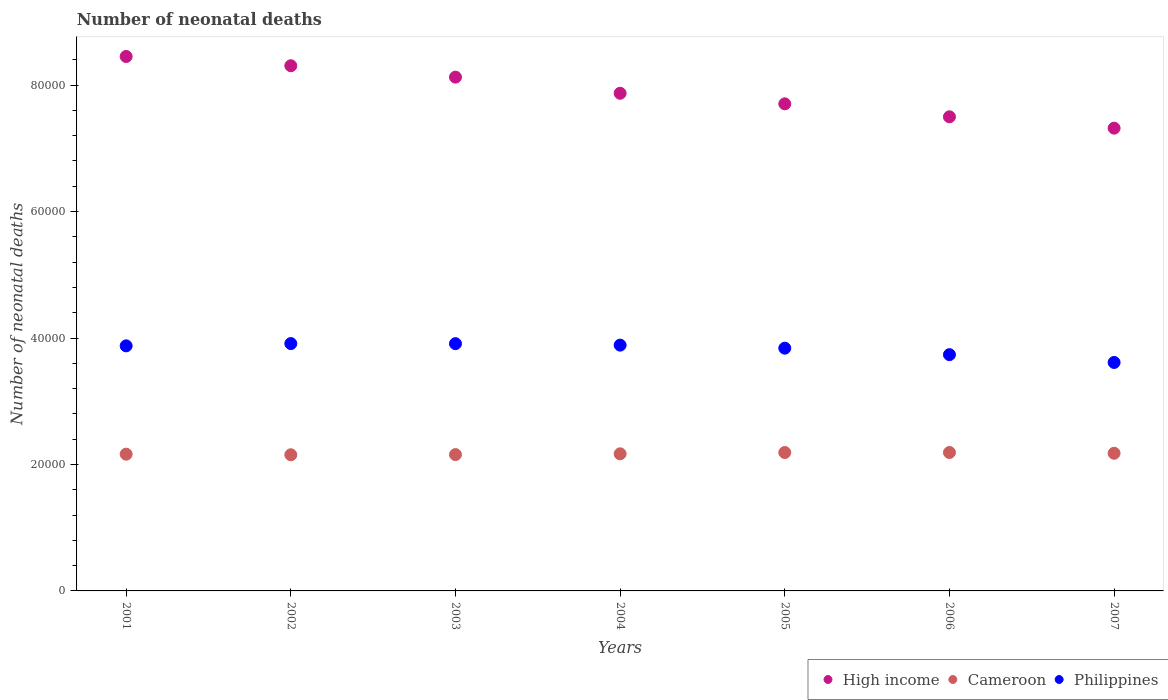How many different coloured dotlines are there?
Offer a very short reply. 3. What is the number of neonatal deaths in in Philippines in 2007?
Offer a very short reply. 3.61e+04. Across all years, what is the maximum number of neonatal deaths in in Philippines?
Give a very brief answer. 3.91e+04. Across all years, what is the minimum number of neonatal deaths in in High income?
Your response must be concise. 7.32e+04. In which year was the number of neonatal deaths in in Cameroon minimum?
Keep it short and to the point. 2002. What is the total number of neonatal deaths in in Philippines in the graph?
Provide a short and direct response. 2.68e+05. What is the difference between the number of neonatal deaths in in Cameroon in 2001 and that in 2002?
Keep it short and to the point. 98. What is the difference between the number of neonatal deaths in in Philippines in 2003 and the number of neonatal deaths in in High income in 2005?
Offer a terse response. -3.79e+04. What is the average number of neonatal deaths in in High income per year?
Keep it short and to the point. 7.90e+04. In the year 2006, what is the difference between the number of neonatal deaths in in High income and number of neonatal deaths in in Philippines?
Give a very brief answer. 3.76e+04. In how many years, is the number of neonatal deaths in in Philippines greater than 60000?
Your answer should be very brief. 0. What is the ratio of the number of neonatal deaths in in High income in 2001 to that in 2003?
Ensure brevity in your answer.  1.04. Is the number of neonatal deaths in in Philippines in 2001 less than that in 2003?
Ensure brevity in your answer.  Yes. What is the difference between the highest and the second highest number of neonatal deaths in in High income?
Your answer should be very brief. 1460. What is the difference between the highest and the lowest number of neonatal deaths in in Philippines?
Offer a terse response. 2985. Is the sum of the number of neonatal deaths in in Cameroon in 2004 and 2007 greater than the maximum number of neonatal deaths in in High income across all years?
Offer a very short reply. No. Is the number of neonatal deaths in in High income strictly greater than the number of neonatal deaths in in Cameroon over the years?
Give a very brief answer. Yes. Is the number of neonatal deaths in in Philippines strictly less than the number of neonatal deaths in in Cameroon over the years?
Keep it short and to the point. No. How many years are there in the graph?
Offer a terse response. 7. Does the graph contain grids?
Ensure brevity in your answer.  No. What is the title of the graph?
Your response must be concise. Number of neonatal deaths. Does "Korea (Republic)" appear as one of the legend labels in the graph?
Give a very brief answer. No. What is the label or title of the X-axis?
Offer a very short reply. Years. What is the label or title of the Y-axis?
Your response must be concise. Number of neonatal deaths. What is the Number of neonatal deaths of High income in 2001?
Ensure brevity in your answer.  8.45e+04. What is the Number of neonatal deaths of Cameroon in 2001?
Give a very brief answer. 2.16e+04. What is the Number of neonatal deaths in Philippines in 2001?
Give a very brief answer. 3.88e+04. What is the Number of neonatal deaths in High income in 2002?
Your response must be concise. 8.31e+04. What is the Number of neonatal deaths in Cameroon in 2002?
Offer a very short reply. 2.15e+04. What is the Number of neonatal deaths of Philippines in 2002?
Your response must be concise. 3.91e+04. What is the Number of neonatal deaths of High income in 2003?
Make the answer very short. 8.13e+04. What is the Number of neonatal deaths in Cameroon in 2003?
Provide a succinct answer. 2.16e+04. What is the Number of neonatal deaths in Philippines in 2003?
Offer a very short reply. 3.91e+04. What is the Number of neonatal deaths in High income in 2004?
Offer a very short reply. 7.87e+04. What is the Number of neonatal deaths of Cameroon in 2004?
Provide a succinct answer. 2.17e+04. What is the Number of neonatal deaths of Philippines in 2004?
Your answer should be very brief. 3.89e+04. What is the Number of neonatal deaths of High income in 2005?
Give a very brief answer. 7.70e+04. What is the Number of neonatal deaths in Cameroon in 2005?
Provide a short and direct response. 2.19e+04. What is the Number of neonatal deaths of Philippines in 2005?
Your answer should be very brief. 3.84e+04. What is the Number of neonatal deaths of High income in 2006?
Keep it short and to the point. 7.50e+04. What is the Number of neonatal deaths in Cameroon in 2006?
Provide a succinct answer. 2.19e+04. What is the Number of neonatal deaths of Philippines in 2006?
Give a very brief answer. 3.74e+04. What is the Number of neonatal deaths in High income in 2007?
Provide a short and direct response. 7.32e+04. What is the Number of neonatal deaths in Cameroon in 2007?
Keep it short and to the point. 2.18e+04. What is the Number of neonatal deaths in Philippines in 2007?
Your answer should be compact. 3.61e+04. Across all years, what is the maximum Number of neonatal deaths in High income?
Provide a short and direct response. 8.45e+04. Across all years, what is the maximum Number of neonatal deaths in Cameroon?
Provide a succinct answer. 2.19e+04. Across all years, what is the maximum Number of neonatal deaths in Philippines?
Provide a succinct answer. 3.91e+04. Across all years, what is the minimum Number of neonatal deaths of High income?
Ensure brevity in your answer.  7.32e+04. Across all years, what is the minimum Number of neonatal deaths of Cameroon?
Ensure brevity in your answer.  2.15e+04. Across all years, what is the minimum Number of neonatal deaths in Philippines?
Make the answer very short. 3.61e+04. What is the total Number of neonatal deaths of High income in the graph?
Your answer should be compact. 5.53e+05. What is the total Number of neonatal deaths in Cameroon in the graph?
Your answer should be very brief. 1.52e+05. What is the total Number of neonatal deaths in Philippines in the graph?
Give a very brief answer. 2.68e+05. What is the difference between the Number of neonatal deaths in High income in 2001 and that in 2002?
Provide a succinct answer. 1460. What is the difference between the Number of neonatal deaths of Cameroon in 2001 and that in 2002?
Offer a terse response. 98. What is the difference between the Number of neonatal deaths in Philippines in 2001 and that in 2002?
Keep it short and to the point. -358. What is the difference between the Number of neonatal deaths in High income in 2001 and that in 2003?
Provide a short and direct response. 3265. What is the difference between the Number of neonatal deaths in Philippines in 2001 and that in 2003?
Your answer should be compact. -346. What is the difference between the Number of neonatal deaths in High income in 2001 and that in 2004?
Provide a short and direct response. 5818. What is the difference between the Number of neonatal deaths of Cameroon in 2001 and that in 2004?
Offer a terse response. -57. What is the difference between the Number of neonatal deaths of Philippines in 2001 and that in 2004?
Offer a very short reply. -114. What is the difference between the Number of neonatal deaths of High income in 2001 and that in 2005?
Offer a very short reply. 7489. What is the difference between the Number of neonatal deaths in Cameroon in 2001 and that in 2005?
Your answer should be compact. -260. What is the difference between the Number of neonatal deaths of Philippines in 2001 and that in 2005?
Provide a succinct answer. 367. What is the difference between the Number of neonatal deaths of High income in 2001 and that in 2006?
Your response must be concise. 9539. What is the difference between the Number of neonatal deaths of Cameroon in 2001 and that in 2006?
Your response must be concise. -264. What is the difference between the Number of neonatal deaths of Philippines in 2001 and that in 2006?
Provide a succinct answer. 1392. What is the difference between the Number of neonatal deaths of High income in 2001 and that in 2007?
Give a very brief answer. 1.13e+04. What is the difference between the Number of neonatal deaths of Cameroon in 2001 and that in 2007?
Give a very brief answer. -143. What is the difference between the Number of neonatal deaths in Philippines in 2001 and that in 2007?
Offer a very short reply. 2627. What is the difference between the Number of neonatal deaths of High income in 2002 and that in 2003?
Make the answer very short. 1805. What is the difference between the Number of neonatal deaths of Cameroon in 2002 and that in 2003?
Offer a terse response. -30. What is the difference between the Number of neonatal deaths in Philippines in 2002 and that in 2003?
Make the answer very short. 12. What is the difference between the Number of neonatal deaths in High income in 2002 and that in 2004?
Provide a short and direct response. 4358. What is the difference between the Number of neonatal deaths in Cameroon in 2002 and that in 2004?
Provide a succinct answer. -155. What is the difference between the Number of neonatal deaths of Philippines in 2002 and that in 2004?
Keep it short and to the point. 244. What is the difference between the Number of neonatal deaths in High income in 2002 and that in 2005?
Ensure brevity in your answer.  6029. What is the difference between the Number of neonatal deaths of Cameroon in 2002 and that in 2005?
Provide a short and direct response. -358. What is the difference between the Number of neonatal deaths in Philippines in 2002 and that in 2005?
Give a very brief answer. 725. What is the difference between the Number of neonatal deaths in High income in 2002 and that in 2006?
Make the answer very short. 8079. What is the difference between the Number of neonatal deaths of Cameroon in 2002 and that in 2006?
Give a very brief answer. -362. What is the difference between the Number of neonatal deaths in Philippines in 2002 and that in 2006?
Give a very brief answer. 1750. What is the difference between the Number of neonatal deaths of High income in 2002 and that in 2007?
Your response must be concise. 9875. What is the difference between the Number of neonatal deaths of Cameroon in 2002 and that in 2007?
Offer a very short reply. -241. What is the difference between the Number of neonatal deaths in Philippines in 2002 and that in 2007?
Ensure brevity in your answer.  2985. What is the difference between the Number of neonatal deaths of High income in 2003 and that in 2004?
Make the answer very short. 2553. What is the difference between the Number of neonatal deaths in Cameroon in 2003 and that in 2004?
Offer a terse response. -125. What is the difference between the Number of neonatal deaths of Philippines in 2003 and that in 2004?
Keep it short and to the point. 232. What is the difference between the Number of neonatal deaths in High income in 2003 and that in 2005?
Your answer should be very brief. 4224. What is the difference between the Number of neonatal deaths in Cameroon in 2003 and that in 2005?
Your answer should be compact. -328. What is the difference between the Number of neonatal deaths of Philippines in 2003 and that in 2005?
Make the answer very short. 713. What is the difference between the Number of neonatal deaths of High income in 2003 and that in 2006?
Keep it short and to the point. 6274. What is the difference between the Number of neonatal deaths in Cameroon in 2003 and that in 2006?
Make the answer very short. -332. What is the difference between the Number of neonatal deaths in Philippines in 2003 and that in 2006?
Ensure brevity in your answer.  1738. What is the difference between the Number of neonatal deaths in High income in 2003 and that in 2007?
Your answer should be compact. 8070. What is the difference between the Number of neonatal deaths of Cameroon in 2003 and that in 2007?
Keep it short and to the point. -211. What is the difference between the Number of neonatal deaths of Philippines in 2003 and that in 2007?
Give a very brief answer. 2973. What is the difference between the Number of neonatal deaths of High income in 2004 and that in 2005?
Provide a succinct answer. 1671. What is the difference between the Number of neonatal deaths of Cameroon in 2004 and that in 2005?
Offer a terse response. -203. What is the difference between the Number of neonatal deaths of Philippines in 2004 and that in 2005?
Give a very brief answer. 481. What is the difference between the Number of neonatal deaths of High income in 2004 and that in 2006?
Offer a very short reply. 3721. What is the difference between the Number of neonatal deaths of Cameroon in 2004 and that in 2006?
Ensure brevity in your answer.  -207. What is the difference between the Number of neonatal deaths in Philippines in 2004 and that in 2006?
Ensure brevity in your answer.  1506. What is the difference between the Number of neonatal deaths of High income in 2004 and that in 2007?
Your answer should be compact. 5517. What is the difference between the Number of neonatal deaths of Cameroon in 2004 and that in 2007?
Make the answer very short. -86. What is the difference between the Number of neonatal deaths of Philippines in 2004 and that in 2007?
Give a very brief answer. 2741. What is the difference between the Number of neonatal deaths in High income in 2005 and that in 2006?
Offer a very short reply. 2050. What is the difference between the Number of neonatal deaths in Cameroon in 2005 and that in 2006?
Give a very brief answer. -4. What is the difference between the Number of neonatal deaths of Philippines in 2005 and that in 2006?
Your answer should be very brief. 1025. What is the difference between the Number of neonatal deaths in High income in 2005 and that in 2007?
Ensure brevity in your answer.  3846. What is the difference between the Number of neonatal deaths of Cameroon in 2005 and that in 2007?
Keep it short and to the point. 117. What is the difference between the Number of neonatal deaths of Philippines in 2005 and that in 2007?
Your answer should be very brief. 2260. What is the difference between the Number of neonatal deaths of High income in 2006 and that in 2007?
Provide a short and direct response. 1796. What is the difference between the Number of neonatal deaths of Cameroon in 2006 and that in 2007?
Ensure brevity in your answer.  121. What is the difference between the Number of neonatal deaths in Philippines in 2006 and that in 2007?
Give a very brief answer. 1235. What is the difference between the Number of neonatal deaths in High income in 2001 and the Number of neonatal deaths in Cameroon in 2002?
Provide a short and direct response. 6.30e+04. What is the difference between the Number of neonatal deaths of High income in 2001 and the Number of neonatal deaths of Philippines in 2002?
Provide a short and direct response. 4.54e+04. What is the difference between the Number of neonatal deaths in Cameroon in 2001 and the Number of neonatal deaths in Philippines in 2002?
Offer a very short reply. -1.75e+04. What is the difference between the Number of neonatal deaths in High income in 2001 and the Number of neonatal deaths in Cameroon in 2003?
Your answer should be compact. 6.30e+04. What is the difference between the Number of neonatal deaths of High income in 2001 and the Number of neonatal deaths of Philippines in 2003?
Your response must be concise. 4.54e+04. What is the difference between the Number of neonatal deaths of Cameroon in 2001 and the Number of neonatal deaths of Philippines in 2003?
Your answer should be compact. -1.75e+04. What is the difference between the Number of neonatal deaths of High income in 2001 and the Number of neonatal deaths of Cameroon in 2004?
Offer a terse response. 6.28e+04. What is the difference between the Number of neonatal deaths of High income in 2001 and the Number of neonatal deaths of Philippines in 2004?
Provide a succinct answer. 4.57e+04. What is the difference between the Number of neonatal deaths in Cameroon in 2001 and the Number of neonatal deaths in Philippines in 2004?
Give a very brief answer. -1.72e+04. What is the difference between the Number of neonatal deaths of High income in 2001 and the Number of neonatal deaths of Cameroon in 2005?
Offer a terse response. 6.26e+04. What is the difference between the Number of neonatal deaths of High income in 2001 and the Number of neonatal deaths of Philippines in 2005?
Provide a succinct answer. 4.61e+04. What is the difference between the Number of neonatal deaths of Cameroon in 2001 and the Number of neonatal deaths of Philippines in 2005?
Your response must be concise. -1.68e+04. What is the difference between the Number of neonatal deaths of High income in 2001 and the Number of neonatal deaths of Cameroon in 2006?
Your response must be concise. 6.26e+04. What is the difference between the Number of neonatal deaths of High income in 2001 and the Number of neonatal deaths of Philippines in 2006?
Ensure brevity in your answer.  4.72e+04. What is the difference between the Number of neonatal deaths in Cameroon in 2001 and the Number of neonatal deaths in Philippines in 2006?
Your answer should be compact. -1.57e+04. What is the difference between the Number of neonatal deaths in High income in 2001 and the Number of neonatal deaths in Cameroon in 2007?
Offer a terse response. 6.28e+04. What is the difference between the Number of neonatal deaths of High income in 2001 and the Number of neonatal deaths of Philippines in 2007?
Give a very brief answer. 4.84e+04. What is the difference between the Number of neonatal deaths in Cameroon in 2001 and the Number of neonatal deaths in Philippines in 2007?
Give a very brief answer. -1.45e+04. What is the difference between the Number of neonatal deaths of High income in 2002 and the Number of neonatal deaths of Cameroon in 2003?
Your answer should be compact. 6.15e+04. What is the difference between the Number of neonatal deaths of High income in 2002 and the Number of neonatal deaths of Philippines in 2003?
Ensure brevity in your answer.  4.40e+04. What is the difference between the Number of neonatal deaths of Cameroon in 2002 and the Number of neonatal deaths of Philippines in 2003?
Offer a terse response. -1.76e+04. What is the difference between the Number of neonatal deaths in High income in 2002 and the Number of neonatal deaths in Cameroon in 2004?
Keep it short and to the point. 6.14e+04. What is the difference between the Number of neonatal deaths of High income in 2002 and the Number of neonatal deaths of Philippines in 2004?
Ensure brevity in your answer.  4.42e+04. What is the difference between the Number of neonatal deaths of Cameroon in 2002 and the Number of neonatal deaths of Philippines in 2004?
Offer a very short reply. -1.73e+04. What is the difference between the Number of neonatal deaths in High income in 2002 and the Number of neonatal deaths in Cameroon in 2005?
Provide a short and direct response. 6.12e+04. What is the difference between the Number of neonatal deaths in High income in 2002 and the Number of neonatal deaths in Philippines in 2005?
Your response must be concise. 4.47e+04. What is the difference between the Number of neonatal deaths in Cameroon in 2002 and the Number of neonatal deaths in Philippines in 2005?
Ensure brevity in your answer.  -1.69e+04. What is the difference between the Number of neonatal deaths of High income in 2002 and the Number of neonatal deaths of Cameroon in 2006?
Offer a very short reply. 6.12e+04. What is the difference between the Number of neonatal deaths in High income in 2002 and the Number of neonatal deaths in Philippines in 2006?
Your answer should be very brief. 4.57e+04. What is the difference between the Number of neonatal deaths of Cameroon in 2002 and the Number of neonatal deaths of Philippines in 2006?
Provide a succinct answer. -1.58e+04. What is the difference between the Number of neonatal deaths of High income in 2002 and the Number of neonatal deaths of Cameroon in 2007?
Provide a succinct answer. 6.13e+04. What is the difference between the Number of neonatal deaths in High income in 2002 and the Number of neonatal deaths in Philippines in 2007?
Offer a terse response. 4.69e+04. What is the difference between the Number of neonatal deaths in Cameroon in 2002 and the Number of neonatal deaths in Philippines in 2007?
Keep it short and to the point. -1.46e+04. What is the difference between the Number of neonatal deaths of High income in 2003 and the Number of neonatal deaths of Cameroon in 2004?
Give a very brief answer. 5.96e+04. What is the difference between the Number of neonatal deaths of High income in 2003 and the Number of neonatal deaths of Philippines in 2004?
Offer a terse response. 4.24e+04. What is the difference between the Number of neonatal deaths in Cameroon in 2003 and the Number of neonatal deaths in Philippines in 2004?
Your answer should be compact. -1.73e+04. What is the difference between the Number of neonatal deaths in High income in 2003 and the Number of neonatal deaths in Cameroon in 2005?
Ensure brevity in your answer.  5.94e+04. What is the difference between the Number of neonatal deaths in High income in 2003 and the Number of neonatal deaths in Philippines in 2005?
Your response must be concise. 4.29e+04. What is the difference between the Number of neonatal deaths in Cameroon in 2003 and the Number of neonatal deaths in Philippines in 2005?
Make the answer very short. -1.68e+04. What is the difference between the Number of neonatal deaths in High income in 2003 and the Number of neonatal deaths in Cameroon in 2006?
Your answer should be compact. 5.94e+04. What is the difference between the Number of neonatal deaths in High income in 2003 and the Number of neonatal deaths in Philippines in 2006?
Give a very brief answer. 4.39e+04. What is the difference between the Number of neonatal deaths of Cameroon in 2003 and the Number of neonatal deaths of Philippines in 2006?
Your answer should be compact. -1.58e+04. What is the difference between the Number of neonatal deaths in High income in 2003 and the Number of neonatal deaths in Cameroon in 2007?
Provide a succinct answer. 5.95e+04. What is the difference between the Number of neonatal deaths in High income in 2003 and the Number of neonatal deaths in Philippines in 2007?
Your answer should be compact. 4.51e+04. What is the difference between the Number of neonatal deaths in Cameroon in 2003 and the Number of neonatal deaths in Philippines in 2007?
Your answer should be very brief. -1.46e+04. What is the difference between the Number of neonatal deaths in High income in 2004 and the Number of neonatal deaths in Cameroon in 2005?
Offer a terse response. 5.68e+04. What is the difference between the Number of neonatal deaths of High income in 2004 and the Number of neonatal deaths of Philippines in 2005?
Ensure brevity in your answer.  4.03e+04. What is the difference between the Number of neonatal deaths of Cameroon in 2004 and the Number of neonatal deaths of Philippines in 2005?
Ensure brevity in your answer.  -1.67e+04. What is the difference between the Number of neonatal deaths in High income in 2004 and the Number of neonatal deaths in Cameroon in 2006?
Ensure brevity in your answer.  5.68e+04. What is the difference between the Number of neonatal deaths in High income in 2004 and the Number of neonatal deaths in Philippines in 2006?
Keep it short and to the point. 4.13e+04. What is the difference between the Number of neonatal deaths in Cameroon in 2004 and the Number of neonatal deaths in Philippines in 2006?
Offer a terse response. -1.57e+04. What is the difference between the Number of neonatal deaths in High income in 2004 and the Number of neonatal deaths in Cameroon in 2007?
Give a very brief answer. 5.69e+04. What is the difference between the Number of neonatal deaths of High income in 2004 and the Number of neonatal deaths of Philippines in 2007?
Your answer should be very brief. 4.26e+04. What is the difference between the Number of neonatal deaths of Cameroon in 2004 and the Number of neonatal deaths of Philippines in 2007?
Make the answer very short. -1.44e+04. What is the difference between the Number of neonatal deaths in High income in 2005 and the Number of neonatal deaths in Cameroon in 2006?
Your answer should be very brief. 5.51e+04. What is the difference between the Number of neonatal deaths of High income in 2005 and the Number of neonatal deaths of Philippines in 2006?
Make the answer very short. 3.97e+04. What is the difference between the Number of neonatal deaths of Cameroon in 2005 and the Number of neonatal deaths of Philippines in 2006?
Your answer should be compact. -1.55e+04. What is the difference between the Number of neonatal deaths of High income in 2005 and the Number of neonatal deaths of Cameroon in 2007?
Give a very brief answer. 5.53e+04. What is the difference between the Number of neonatal deaths of High income in 2005 and the Number of neonatal deaths of Philippines in 2007?
Make the answer very short. 4.09e+04. What is the difference between the Number of neonatal deaths of Cameroon in 2005 and the Number of neonatal deaths of Philippines in 2007?
Your answer should be compact. -1.42e+04. What is the difference between the Number of neonatal deaths in High income in 2006 and the Number of neonatal deaths in Cameroon in 2007?
Your answer should be very brief. 5.32e+04. What is the difference between the Number of neonatal deaths in High income in 2006 and the Number of neonatal deaths in Philippines in 2007?
Ensure brevity in your answer.  3.89e+04. What is the difference between the Number of neonatal deaths in Cameroon in 2006 and the Number of neonatal deaths in Philippines in 2007?
Your answer should be compact. -1.42e+04. What is the average Number of neonatal deaths of High income per year?
Your answer should be very brief. 7.90e+04. What is the average Number of neonatal deaths in Cameroon per year?
Make the answer very short. 2.17e+04. What is the average Number of neonatal deaths of Philippines per year?
Provide a succinct answer. 3.83e+04. In the year 2001, what is the difference between the Number of neonatal deaths of High income and Number of neonatal deaths of Cameroon?
Ensure brevity in your answer.  6.29e+04. In the year 2001, what is the difference between the Number of neonatal deaths of High income and Number of neonatal deaths of Philippines?
Provide a succinct answer. 4.58e+04. In the year 2001, what is the difference between the Number of neonatal deaths of Cameroon and Number of neonatal deaths of Philippines?
Give a very brief answer. -1.71e+04. In the year 2002, what is the difference between the Number of neonatal deaths of High income and Number of neonatal deaths of Cameroon?
Keep it short and to the point. 6.15e+04. In the year 2002, what is the difference between the Number of neonatal deaths of High income and Number of neonatal deaths of Philippines?
Keep it short and to the point. 4.39e+04. In the year 2002, what is the difference between the Number of neonatal deaths of Cameroon and Number of neonatal deaths of Philippines?
Your answer should be compact. -1.76e+04. In the year 2003, what is the difference between the Number of neonatal deaths of High income and Number of neonatal deaths of Cameroon?
Provide a short and direct response. 5.97e+04. In the year 2003, what is the difference between the Number of neonatal deaths in High income and Number of neonatal deaths in Philippines?
Your answer should be very brief. 4.22e+04. In the year 2003, what is the difference between the Number of neonatal deaths in Cameroon and Number of neonatal deaths in Philippines?
Make the answer very short. -1.75e+04. In the year 2004, what is the difference between the Number of neonatal deaths in High income and Number of neonatal deaths in Cameroon?
Provide a succinct answer. 5.70e+04. In the year 2004, what is the difference between the Number of neonatal deaths of High income and Number of neonatal deaths of Philippines?
Keep it short and to the point. 3.98e+04. In the year 2004, what is the difference between the Number of neonatal deaths of Cameroon and Number of neonatal deaths of Philippines?
Provide a succinct answer. -1.72e+04. In the year 2005, what is the difference between the Number of neonatal deaths of High income and Number of neonatal deaths of Cameroon?
Offer a very short reply. 5.51e+04. In the year 2005, what is the difference between the Number of neonatal deaths of High income and Number of neonatal deaths of Philippines?
Provide a short and direct response. 3.86e+04. In the year 2005, what is the difference between the Number of neonatal deaths of Cameroon and Number of neonatal deaths of Philippines?
Keep it short and to the point. -1.65e+04. In the year 2006, what is the difference between the Number of neonatal deaths in High income and Number of neonatal deaths in Cameroon?
Offer a very short reply. 5.31e+04. In the year 2006, what is the difference between the Number of neonatal deaths of High income and Number of neonatal deaths of Philippines?
Your answer should be compact. 3.76e+04. In the year 2006, what is the difference between the Number of neonatal deaths of Cameroon and Number of neonatal deaths of Philippines?
Provide a short and direct response. -1.55e+04. In the year 2007, what is the difference between the Number of neonatal deaths of High income and Number of neonatal deaths of Cameroon?
Provide a short and direct response. 5.14e+04. In the year 2007, what is the difference between the Number of neonatal deaths in High income and Number of neonatal deaths in Philippines?
Keep it short and to the point. 3.71e+04. In the year 2007, what is the difference between the Number of neonatal deaths of Cameroon and Number of neonatal deaths of Philippines?
Ensure brevity in your answer.  -1.44e+04. What is the ratio of the Number of neonatal deaths in High income in 2001 to that in 2002?
Offer a very short reply. 1.02. What is the ratio of the Number of neonatal deaths of Cameroon in 2001 to that in 2002?
Keep it short and to the point. 1. What is the ratio of the Number of neonatal deaths of Philippines in 2001 to that in 2002?
Ensure brevity in your answer.  0.99. What is the ratio of the Number of neonatal deaths in High income in 2001 to that in 2003?
Your response must be concise. 1.04. What is the ratio of the Number of neonatal deaths in Philippines in 2001 to that in 2003?
Provide a succinct answer. 0.99. What is the ratio of the Number of neonatal deaths of High income in 2001 to that in 2004?
Provide a short and direct response. 1.07. What is the ratio of the Number of neonatal deaths in Philippines in 2001 to that in 2004?
Your answer should be very brief. 1. What is the ratio of the Number of neonatal deaths in High income in 2001 to that in 2005?
Offer a very short reply. 1.1. What is the ratio of the Number of neonatal deaths in Philippines in 2001 to that in 2005?
Offer a terse response. 1.01. What is the ratio of the Number of neonatal deaths of High income in 2001 to that in 2006?
Provide a short and direct response. 1.13. What is the ratio of the Number of neonatal deaths of Cameroon in 2001 to that in 2006?
Offer a terse response. 0.99. What is the ratio of the Number of neonatal deaths of Philippines in 2001 to that in 2006?
Provide a short and direct response. 1.04. What is the ratio of the Number of neonatal deaths of High income in 2001 to that in 2007?
Provide a succinct answer. 1.15. What is the ratio of the Number of neonatal deaths of Philippines in 2001 to that in 2007?
Your response must be concise. 1.07. What is the ratio of the Number of neonatal deaths in High income in 2002 to that in 2003?
Provide a succinct answer. 1.02. What is the ratio of the Number of neonatal deaths of High income in 2002 to that in 2004?
Your answer should be compact. 1.06. What is the ratio of the Number of neonatal deaths of Philippines in 2002 to that in 2004?
Your response must be concise. 1.01. What is the ratio of the Number of neonatal deaths in High income in 2002 to that in 2005?
Give a very brief answer. 1.08. What is the ratio of the Number of neonatal deaths in Cameroon in 2002 to that in 2005?
Offer a very short reply. 0.98. What is the ratio of the Number of neonatal deaths in Philippines in 2002 to that in 2005?
Provide a succinct answer. 1.02. What is the ratio of the Number of neonatal deaths in High income in 2002 to that in 2006?
Give a very brief answer. 1.11. What is the ratio of the Number of neonatal deaths of Cameroon in 2002 to that in 2006?
Offer a very short reply. 0.98. What is the ratio of the Number of neonatal deaths of Philippines in 2002 to that in 2006?
Offer a very short reply. 1.05. What is the ratio of the Number of neonatal deaths in High income in 2002 to that in 2007?
Offer a terse response. 1.13. What is the ratio of the Number of neonatal deaths in Cameroon in 2002 to that in 2007?
Your answer should be very brief. 0.99. What is the ratio of the Number of neonatal deaths of Philippines in 2002 to that in 2007?
Your answer should be compact. 1.08. What is the ratio of the Number of neonatal deaths of High income in 2003 to that in 2004?
Offer a terse response. 1.03. What is the ratio of the Number of neonatal deaths in High income in 2003 to that in 2005?
Ensure brevity in your answer.  1.05. What is the ratio of the Number of neonatal deaths of Cameroon in 2003 to that in 2005?
Offer a very short reply. 0.98. What is the ratio of the Number of neonatal deaths of Philippines in 2003 to that in 2005?
Your response must be concise. 1.02. What is the ratio of the Number of neonatal deaths in High income in 2003 to that in 2006?
Keep it short and to the point. 1.08. What is the ratio of the Number of neonatal deaths in Cameroon in 2003 to that in 2006?
Keep it short and to the point. 0.98. What is the ratio of the Number of neonatal deaths of Philippines in 2003 to that in 2006?
Provide a short and direct response. 1.05. What is the ratio of the Number of neonatal deaths in High income in 2003 to that in 2007?
Offer a terse response. 1.11. What is the ratio of the Number of neonatal deaths in Cameroon in 2003 to that in 2007?
Provide a succinct answer. 0.99. What is the ratio of the Number of neonatal deaths of Philippines in 2003 to that in 2007?
Make the answer very short. 1.08. What is the ratio of the Number of neonatal deaths in High income in 2004 to that in 2005?
Offer a terse response. 1.02. What is the ratio of the Number of neonatal deaths in Cameroon in 2004 to that in 2005?
Provide a succinct answer. 0.99. What is the ratio of the Number of neonatal deaths of Philippines in 2004 to that in 2005?
Make the answer very short. 1.01. What is the ratio of the Number of neonatal deaths of High income in 2004 to that in 2006?
Give a very brief answer. 1.05. What is the ratio of the Number of neonatal deaths of Philippines in 2004 to that in 2006?
Make the answer very short. 1.04. What is the ratio of the Number of neonatal deaths in High income in 2004 to that in 2007?
Give a very brief answer. 1.08. What is the ratio of the Number of neonatal deaths in Cameroon in 2004 to that in 2007?
Your answer should be compact. 1. What is the ratio of the Number of neonatal deaths in Philippines in 2004 to that in 2007?
Your answer should be very brief. 1.08. What is the ratio of the Number of neonatal deaths of High income in 2005 to that in 2006?
Offer a terse response. 1.03. What is the ratio of the Number of neonatal deaths in Cameroon in 2005 to that in 2006?
Offer a terse response. 1. What is the ratio of the Number of neonatal deaths in Philippines in 2005 to that in 2006?
Your answer should be very brief. 1.03. What is the ratio of the Number of neonatal deaths in High income in 2005 to that in 2007?
Your response must be concise. 1.05. What is the ratio of the Number of neonatal deaths in Cameroon in 2005 to that in 2007?
Your answer should be compact. 1.01. What is the ratio of the Number of neonatal deaths in High income in 2006 to that in 2007?
Provide a short and direct response. 1.02. What is the ratio of the Number of neonatal deaths of Cameroon in 2006 to that in 2007?
Your answer should be compact. 1.01. What is the ratio of the Number of neonatal deaths in Philippines in 2006 to that in 2007?
Provide a succinct answer. 1.03. What is the difference between the highest and the second highest Number of neonatal deaths of High income?
Keep it short and to the point. 1460. What is the difference between the highest and the second highest Number of neonatal deaths in Philippines?
Provide a short and direct response. 12. What is the difference between the highest and the lowest Number of neonatal deaths of High income?
Offer a terse response. 1.13e+04. What is the difference between the highest and the lowest Number of neonatal deaths of Cameroon?
Provide a succinct answer. 362. What is the difference between the highest and the lowest Number of neonatal deaths of Philippines?
Provide a succinct answer. 2985. 